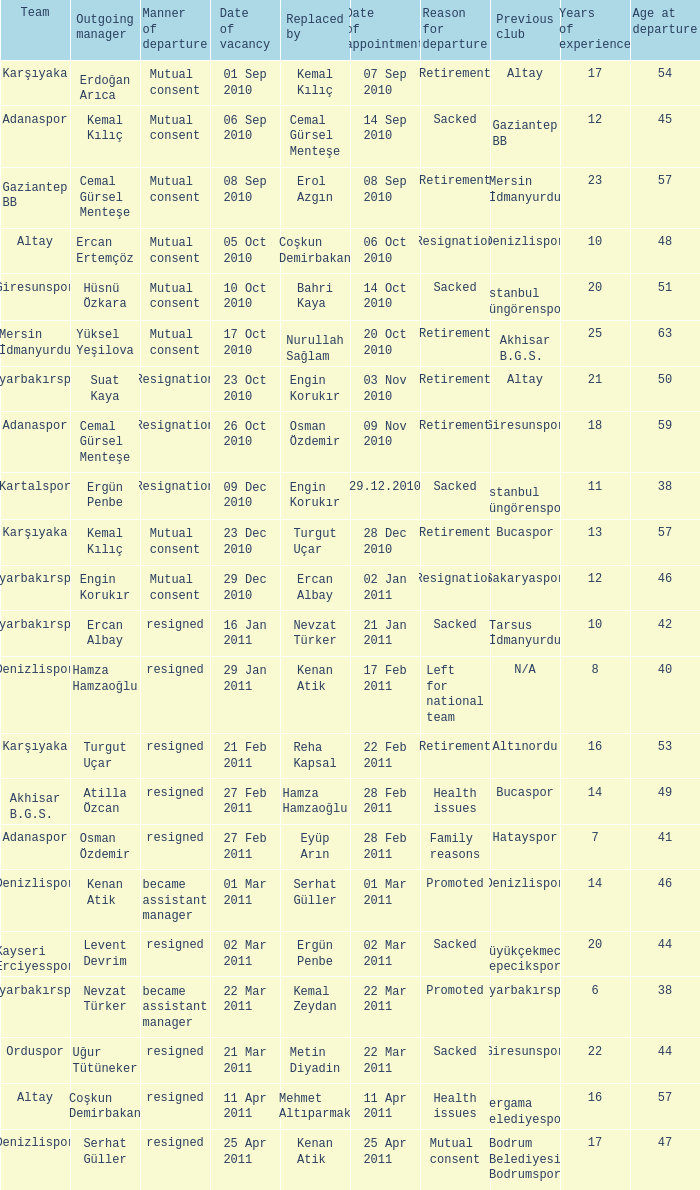When was the date of vacancy for the manager of Kartalspor?  09 Dec 2010. 